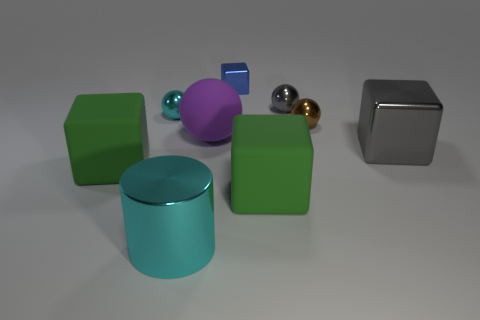Subtract all rubber spheres. How many spheres are left? 3 Subtract all green cubes. How many cubes are left? 2 Subtract 2 spheres. How many spheres are left? 2 Subtract all blue cubes. How many green cylinders are left? 0 Subtract all large matte cubes. Subtract all rubber objects. How many objects are left? 4 Add 8 small gray spheres. How many small gray spheres are left? 9 Add 6 large gray shiny cubes. How many large gray shiny cubes exist? 7 Add 1 large rubber objects. How many objects exist? 10 Subtract 0 green balls. How many objects are left? 9 Subtract all cylinders. How many objects are left? 8 